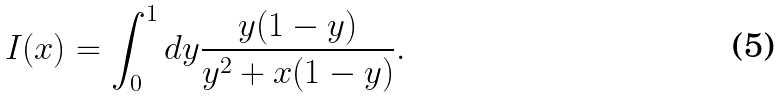Convert formula to latex. <formula><loc_0><loc_0><loc_500><loc_500>I ( x ) = \int _ { 0 } ^ { 1 } d y { \frac { y ( 1 - y ) } { y ^ { 2 } + x ( 1 - y ) } } .</formula> 